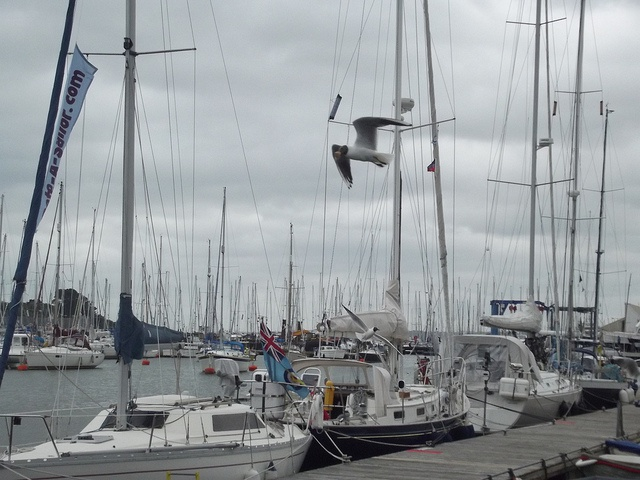Describe the objects in this image and their specific colors. I can see boat in darkgray, gray, and black tones, boat in darkgray, gray, black, and lightgray tones, boat in darkgray, gray, and black tones, boat in darkgray, gray, and black tones, and boat in darkgray, gray, and black tones in this image. 